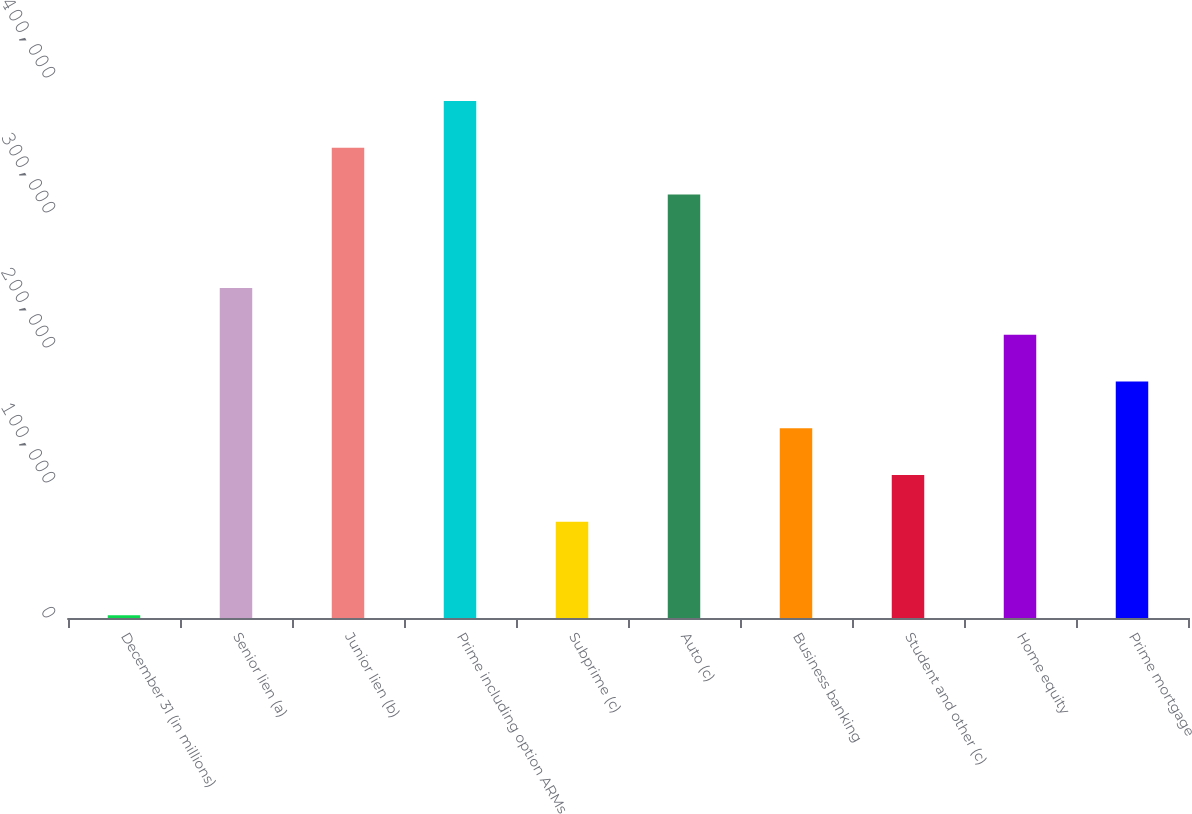Convert chart to OTSL. <chart><loc_0><loc_0><loc_500><loc_500><bar_chart><fcel>December 31 (in millions)<fcel>Senior lien (a)<fcel>Junior lien (b)<fcel>Prime including option ARMs<fcel>Subprime (c)<fcel>Auto (c)<fcel>Business banking<fcel>Student and other (c)<fcel>Home equity<fcel>Prime mortgage<nl><fcel>2009<fcel>244451<fcel>348355<fcel>382990<fcel>71278.2<fcel>313720<fcel>140547<fcel>105913<fcel>209817<fcel>175182<nl></chart> 